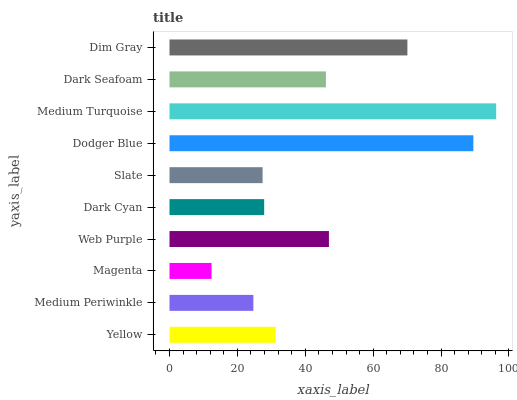Is Magenta the minimum?
Answer yes or no. Yes. Is Medium Turquoise the maximum?
Answer yes or no. Yes. Is Medium Periwinkle the minimum?
Answer yes or no. No. Is Medium Periwinkle the maximum?
Answer yes or no. No. Is Yellow greater than Medium Periwinkle?
Answer yes or no. Yes. Is Medium Periwinkle less than Yellow?
Answer yes or no. Yes. Is Medium Periwinkle greater than Yellow?
Answer yes or no. No. Is Yellow less than Medium Periwinkle?
Answer yes or no. No. Is Dark Seafoam the high median?
Answer yes or no. Yes. Is Yellow the low median?
Answer yes or no. Yes. Is Yellow the high median?
Answer yes or no. No. Is Dark Cyan the low median?
Answer yes or no. No. 